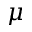<formula> <loc_0><loc_0><loc_500><loc_500>\mu</formula> 